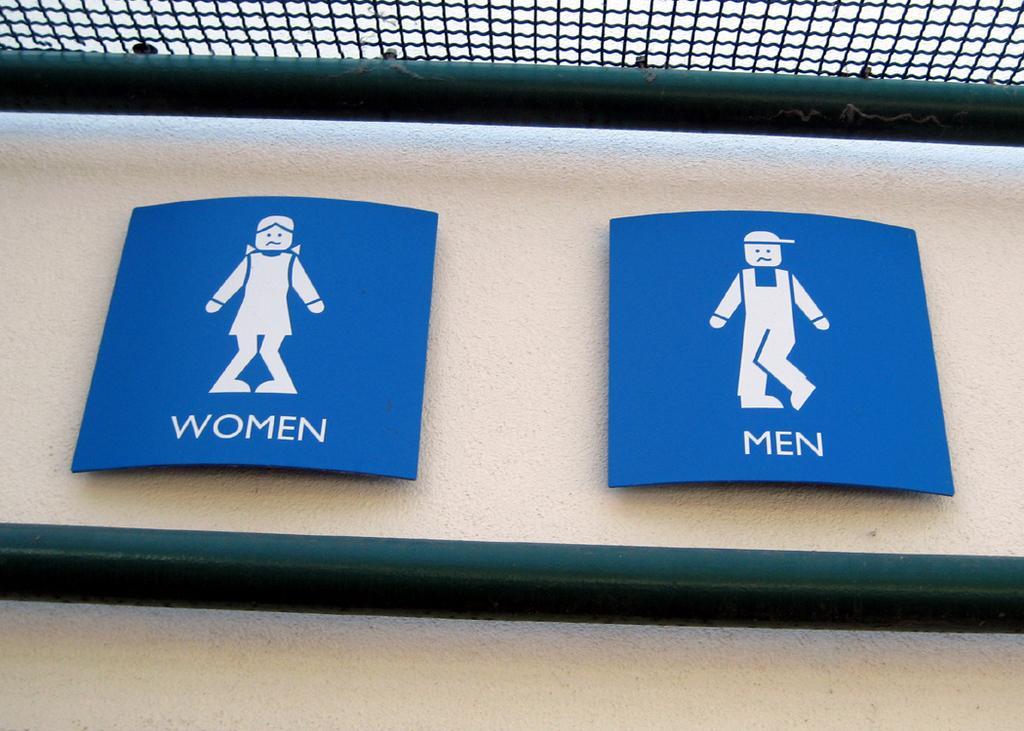Could you give a brief overview of what you see in this image? In this image there is a wall, on the wall there are two blue color boards attached, in the board there are pictorial representation of men and women visible , on the wall there is a rod,at the top there is another rod and fence visible. 